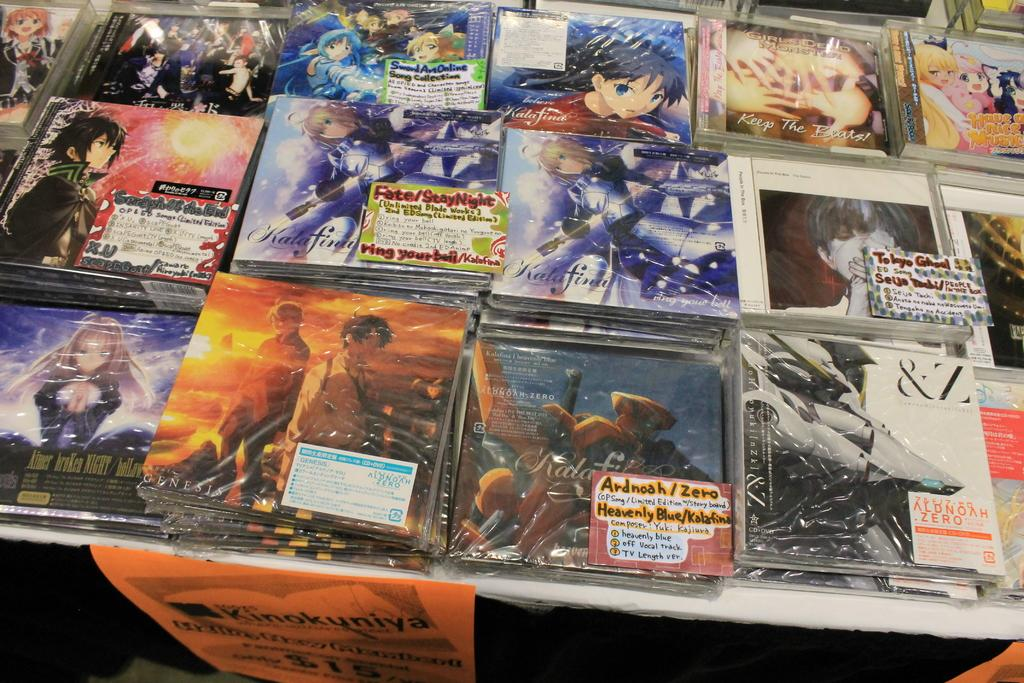Provide a one-sentence caption for the provided image. A Keep the Beats CD is on a table with many other CDs. 